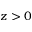Convert formula to latex. <formula><loc_0><loc_0><loc_500><loc_500>z > 0</formula> 